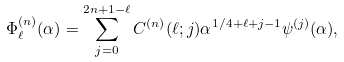Convert formula to latex. <formula><loc_0><loc_0><loc_500><loc_500>\Phi _ { \ell } ^ { ( n ) } ( \alpha ) = \sum _ { j = 0 } ^ { 2 n + 1 - \ell } C ^ { ( n ) } ( \ell ; j ) \alpha ^ { 1 / 4 + \ell + j - 1 } \psi ^ { ( j ) } ( \alpha ) ,</formula> 